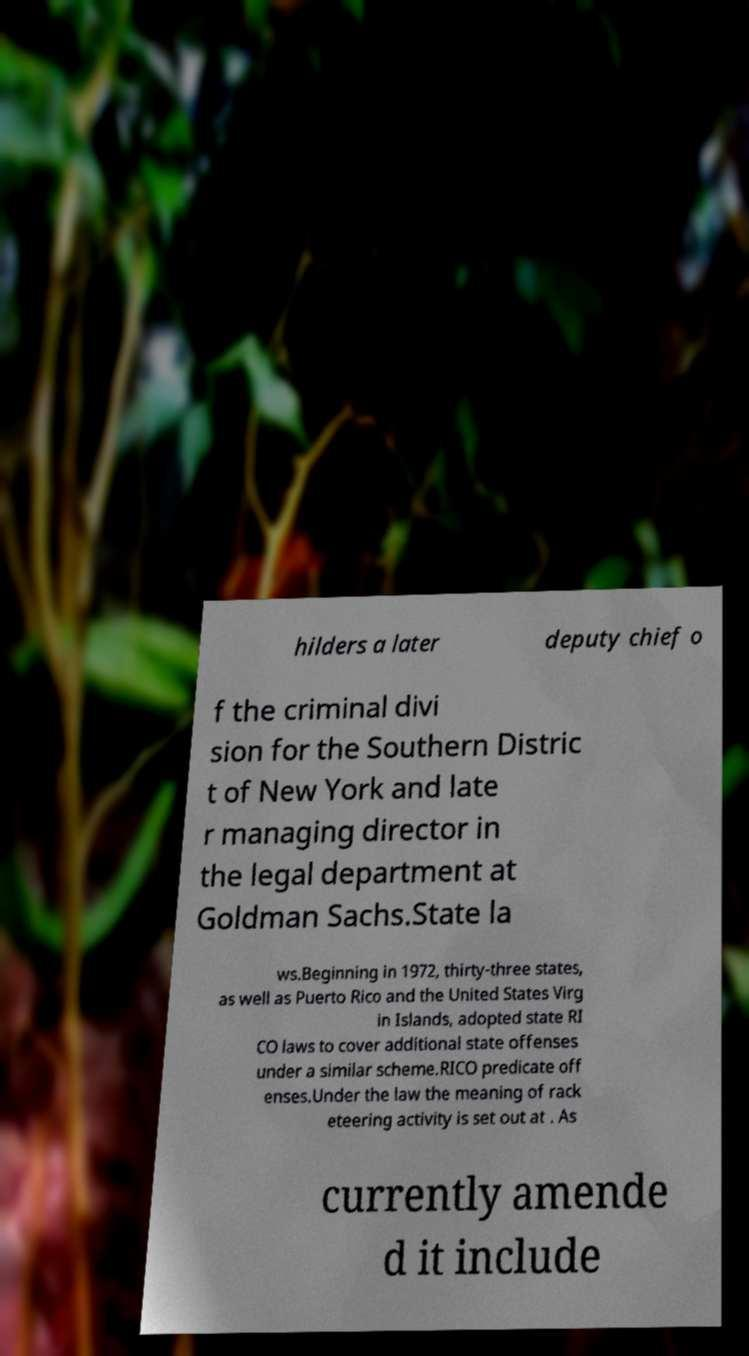For documentation purposes, I need the text within this image transcribed. Could you provide that? hilders a later deputy chief o f the criminal divi sion for the Southern Distric t of New York and late r managing director in the legal department at Goldman Sachs.State la ws.Beginning in 1972, thirty-three states, as well as Puerto Rico and the United States Virg in Islands, adopted state RI CO laws to cover additional state offenses under a similar scheme.RICO predicate off enses.Under the law the meaning of rack eteering activity is set out at . As currently amende d it include 